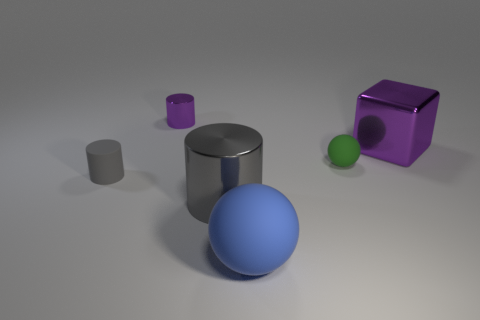What is the shape of the matte object that is in front of the tiny rubber thing left of the tiny purple cylinder?
Offer a terse response. Sphere. Is the number of gray metallic objects left of the tiny gray cylinder less than the number of large cyan matte objects?
Keep it short and to the point. No. What is the shape of the big shiny thing that is the same color as the tiny metal object?
Your answer should be compact. Cube. What number of gray metal cylinders are the same size as the blue sphere?
Your answer should be compact. 1. The big metallic object to the left of the small green ball has what shape?
Your answer should be very brief. Cylinder. Is the number of tiny gray matte cylinders less than the number of purple things?
Your answer should be compact. Yes. Is there any other thing that is the same color as the large sphere?
Ensure brevity in your answer.  No. How big is the metal cylinder that is in front of the small green object?
Provide a succinct answer. Large. Are there more blue blocks than small rubber spheres?
Your response must be concise. No. What is the material of the tiny purple cylinder?
Make the answer very short. Metal. 